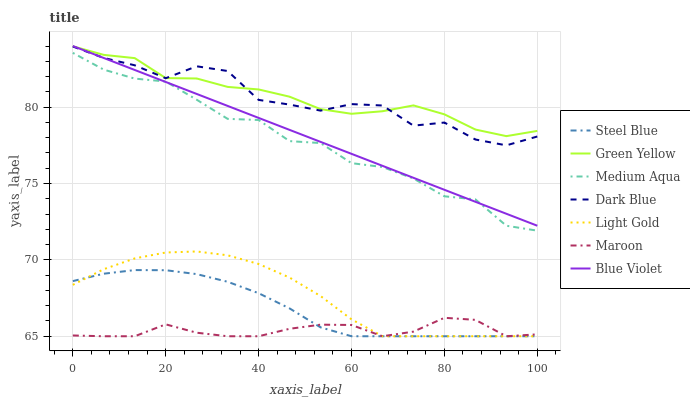Does Maroon have the minimum area under the curve?
Answer yes or no. Yes. Does Green Yellow have the maximum area under the curve?
Answer yes or no. Yes. Does Dark Blue have the minimum area under the curve?
Answer yes or no. No. Does Dark Blue have the maximum area under the curve?
Answer yes or no. No. Is Blue Violet the smoothest?
Answer yes or no. Yes. Is Dark Blue the roughest?
Answer yes or no. Yes. Is Maroon the smoothest?
Answer yes or no. No. Is Maroon the roughest?
Answer yes or no. No. Does Steel Blue have the lowest value?
Answer yes or no. Yes. Does Dark Blue have the lowest value?
Answer yes or no. No. Does Blue Violet have the highest value?
Answer yes or no. Yes. Does Dark Blue have the highest value?
Answer yes or no. No. Is Medium Aqua less than Green Yellow?
Answer yes or no. Yes. Is Blue Violet greater than Steel Blue?
Answer yes or no. Yes. Does Blue Violet intersect Dark Blue?
Answer yes or no. Yes. Is Blue Violet less than Dark Blue?
Answer yes or no. No. Is Blue Violet greater than Dark Blue?
Answer yes or no. No. Does Medium Aqua intersect Green Yellow?
Answer yes or no. No. 